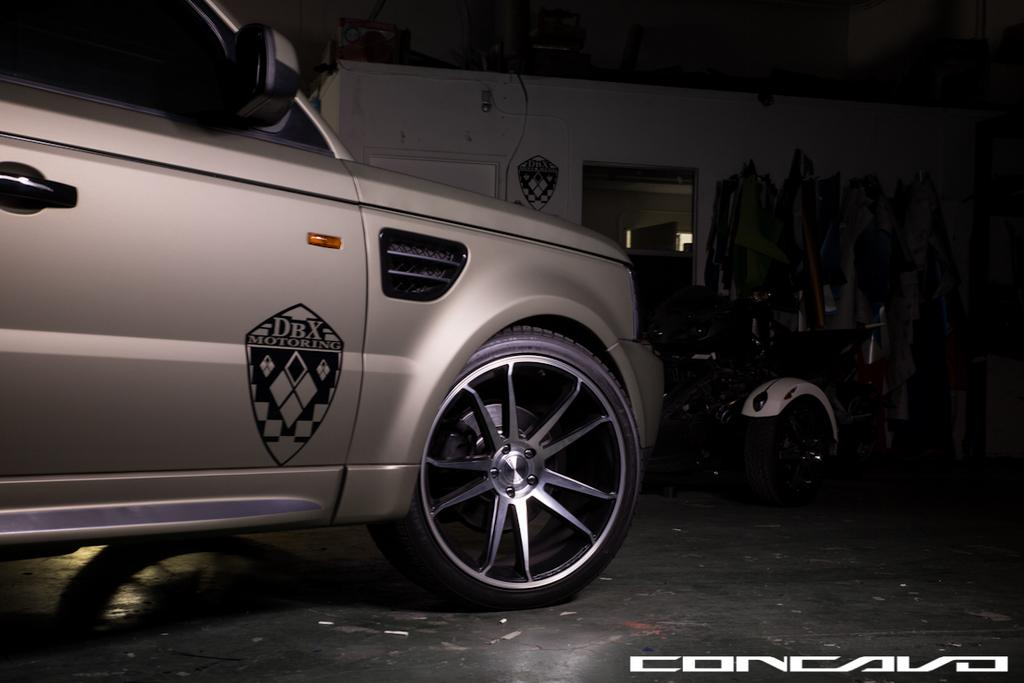What type of space is depicted in the image? There is a room in the image. Can you describe anything outside the room? There is another vehicle in front of the room. What type of note is being passed between the faces in the image? There are no faces present in the image, and therefore no note can be passed between them. 